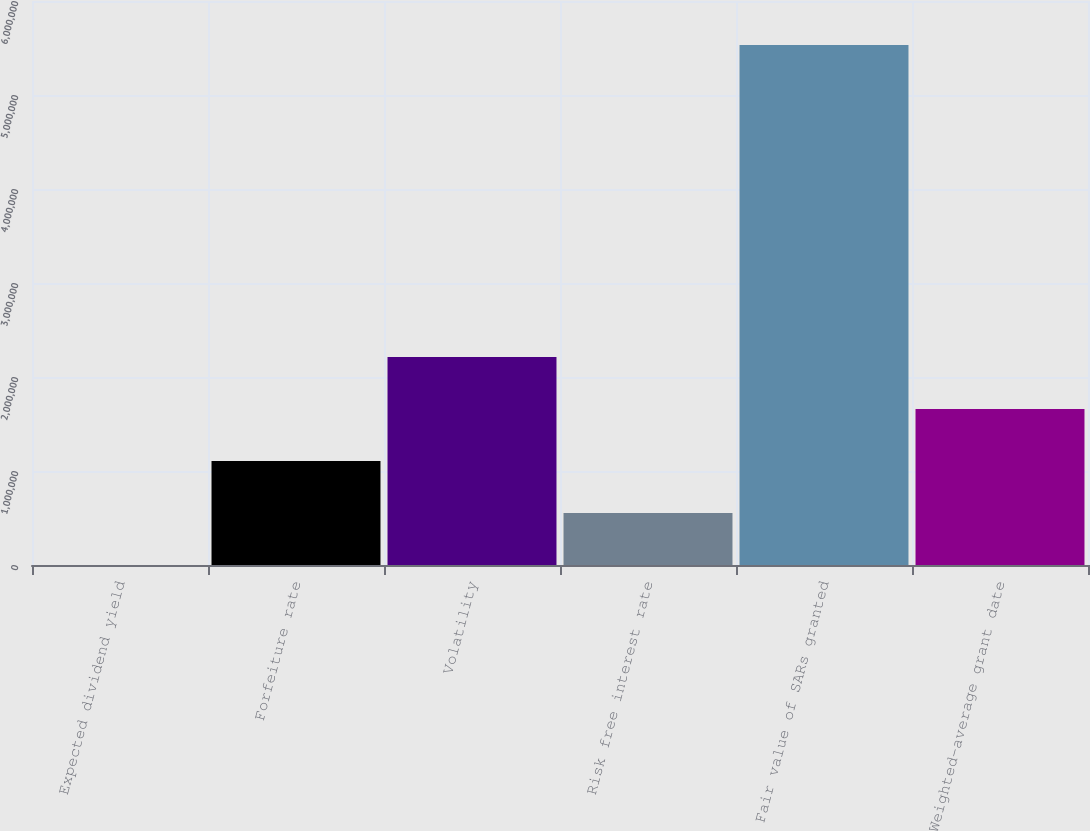Convert chart. <chart><loc_0><loc_0><loc_500><loc_500><bar_chart><fcel>Expected dividend yield<fcel>Forfeiture rate<fcel>Volatility<fcel>Risk free interest rate<fcel>Fair value of SARs granted<fcel>Weighted-average grant date<nl><fcel>0.48<fcel>1.1066e+06<fcel>2.2132e+06<fcel>553300<fcel>5.533e+06<fcel>1.6599e+06<nl></chart> 